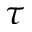<formula> <loc_0><loc_0><loc_500><loc_500>\tau</formula> 